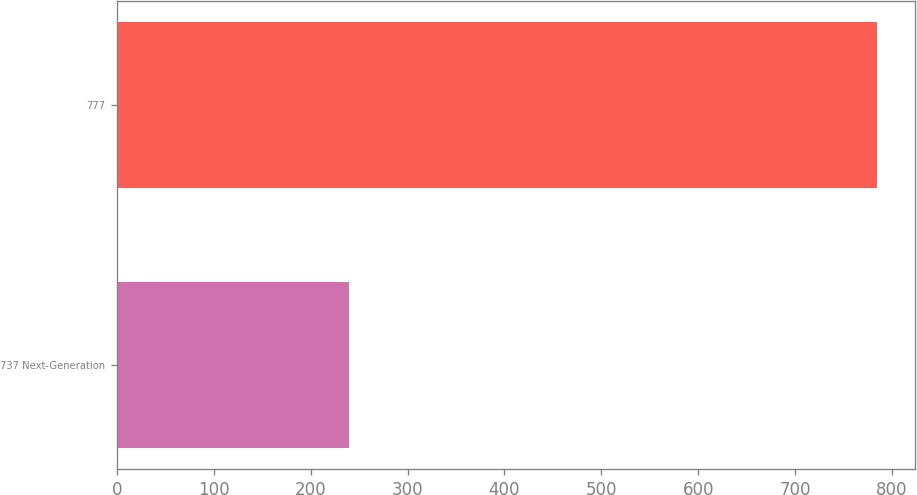<chart> <loc_0><loc_0><loc_500><loc_500><bar_chart><fcel>737 Next-Generation<fcel>777<nl><fcel>239<fcel>785<nl></chart> 